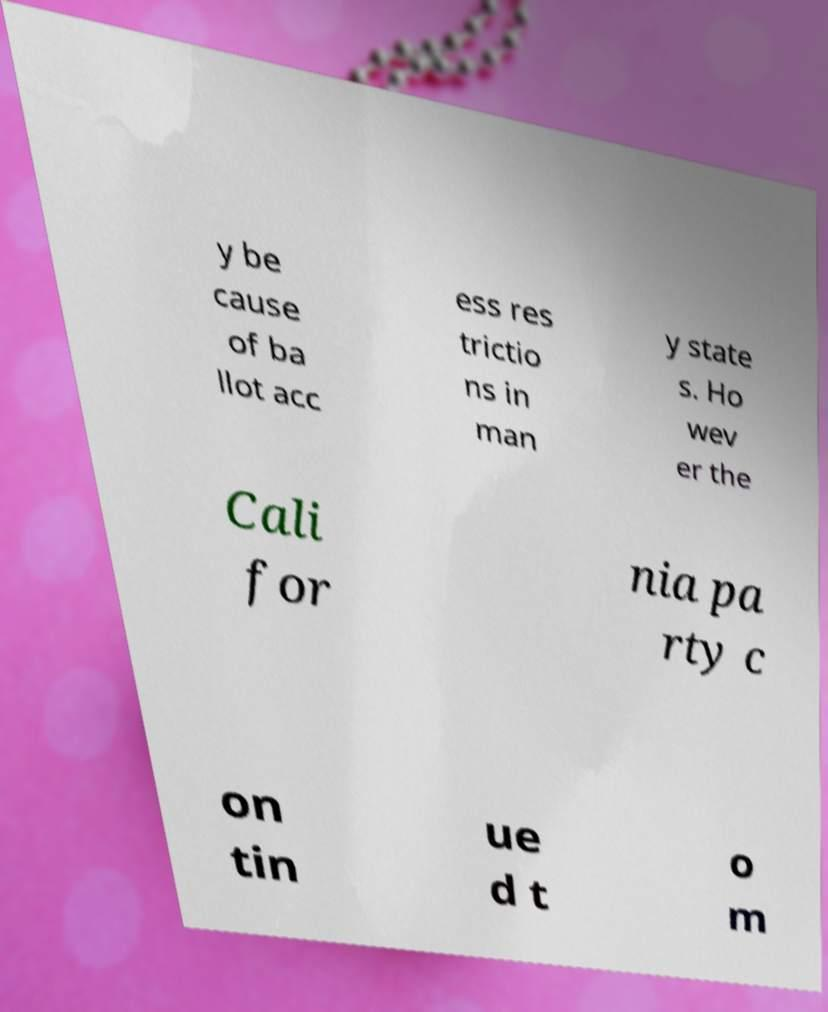There's text embedded in this image that I need extracted. Can you transcribe it verbatim? y be cause of ba llot acc ess res trictio ns in man y state s. Ho wev er the Cali for nia pa rty c on tin ue d t o m 